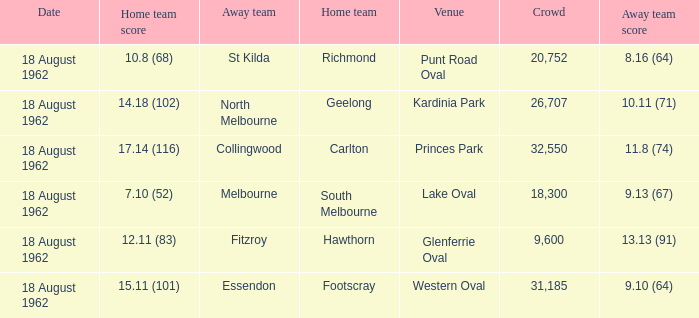What was the home team when the away team scored 9.10 (64)? Footscray. Give me the full table as a dictionary. {'header': ['Date', 'Home team score', 'Away team', 'Home team', 'Venue', 'Crowd', 'Away team score'], 'rows': [['18 August 1962', '10.8 (68)', 'St Kilda', 'Richmond', 'Punt Road Oval', '20,752', '8.16 (64)'], ['18 August 1962', '14.18 (102)', 'North Melbourne', 'Geelong', 'Kardinia Park', '26,707', '10.11 (71)'], ['18 August 1962', '17.14 (116)', 'Collingwood', 'Carlton', 'Princes Park', '32,550', '11.8 (74)'], ['18 August 1962', '7.10 (52)', 'Melbourne', 'South Melbourne', 'Lake Oval', '18,300', '9.13 (67)'], ['18 August 1962', '12.11 (83)', 'Fitzroy', 'Hawthorn', 'Glenferrie Oval', '9,600', '13.13 (91)'], ['18 August 1962', '15.11 (101)', 'Essendon', 'Footscray', 'Western Oval', '31,185', '9.10 (64)']]} 